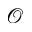Convert formula to latex. <formula><loc_0><loc_0><loc_500><loc_500>\mathcal { O }</formula> 